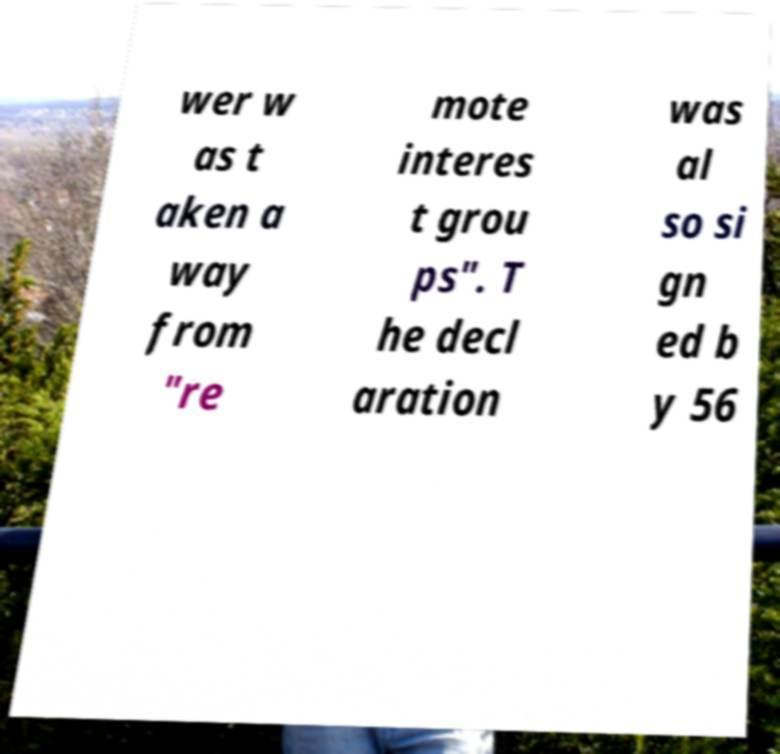Could you assist in decoding the text presented in this image and type it out clearly? wer w as t aken a way from "re mote interes t grou ps". T he decl aration was al so si gn ed b y 56 